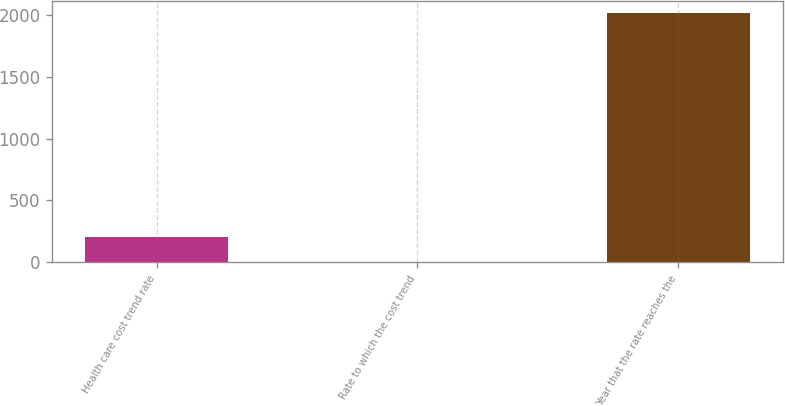Convert chart. <chart><loc_0><loc_0><loc_500><loc_500><bar_chart><fcel>Health care cost trend rate<fcel>Rate to which the cost trend<fcel>Year that the rate reaches the<nl><fcel>206.1<fcel>5<fcel>2016<nl></chart> 